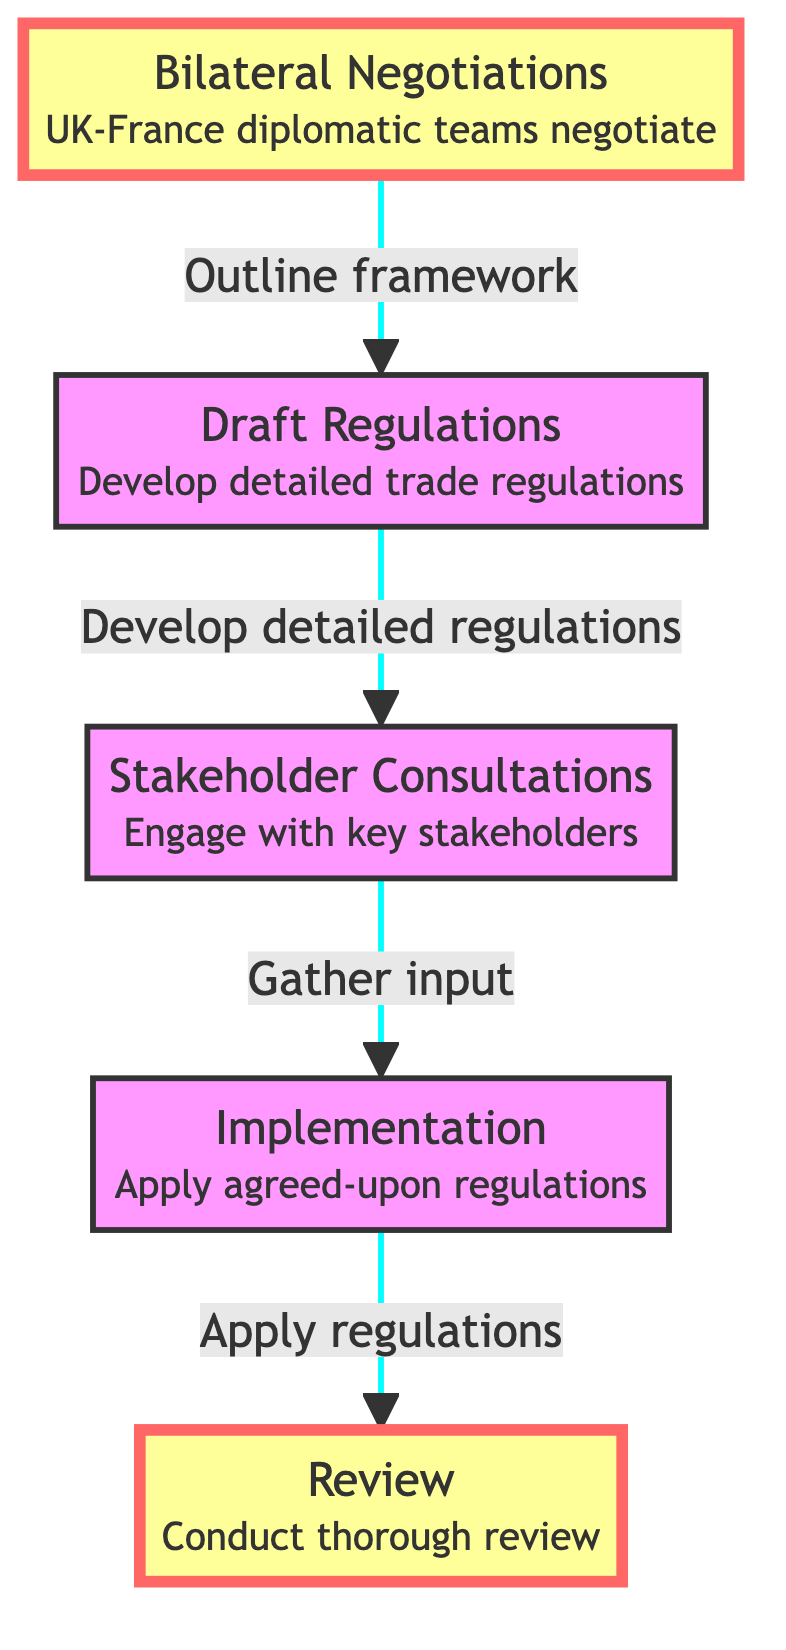What is the first step in the flowchart? The flowchart starts with "Bilateral Negotiations," which is the first process in establishing post-Brexit trade regulations.
Answer: Bilateral Negotiations How many total steps are present in the diagram? The diagram consists of five steps outlining the process from negotiations to review, specifically: Bilateral Negotiations, Draft Regulations, Stakeholder Consultations, Implementation, and Review.
Answer: Five What follows after the 'Stakeholder Consultations'? According to the flowchart, 'Implementation' immediately follows 'Stakeholder Consultations', indicating that once consultations are done, the implementation of regulations begins.
Answer: Implementation Which step involves engaging with key stakeholders? 'Stakeholder Consultations' is the step dedicated to engaging with key stakeholders to gather input and address concerns regarding the trade regulations.
Answer: Stakeholder Consultations What is the last step in the flowchart? The final step in the flowchart is 'Review', which involves conducting a thorough examination of the post-Brexit trade regulations to identify necessary adjustments or improvements.
Answer: Review Which two steps are highlighted in the diagram? The flowchart highlights the 'Bilateral Negotiations' and 'Review' steps, indicating their importance in the overall process of establishing trade regulations.
Answer: Bilateral Negotiations, Review What is the connection between 'Draft Regulations' and 'Implementation'? The flowchart specifies that 'Draft Regulations' lead to 'Stakeholder Consultations', which are then followed by 'Implementation', establishing a clear sequence from drafting to applying the regulations.
Answer: Stakeholder Consultations What type of consultations are performed in the process? The consultations performed in this process are called 'Stakeholder Consultations', focusing on engaging key stakeholders such as businesses and regulatory bodies for input.
Answer: Stakeholder Consultations Which step requires alignment with UK and French laws? The step entitled 'Draft Regulations' requires consultation with legal and economic experts to ensure the regulations align with both UK and French laws during their development.
Answer: Draft Regulations 